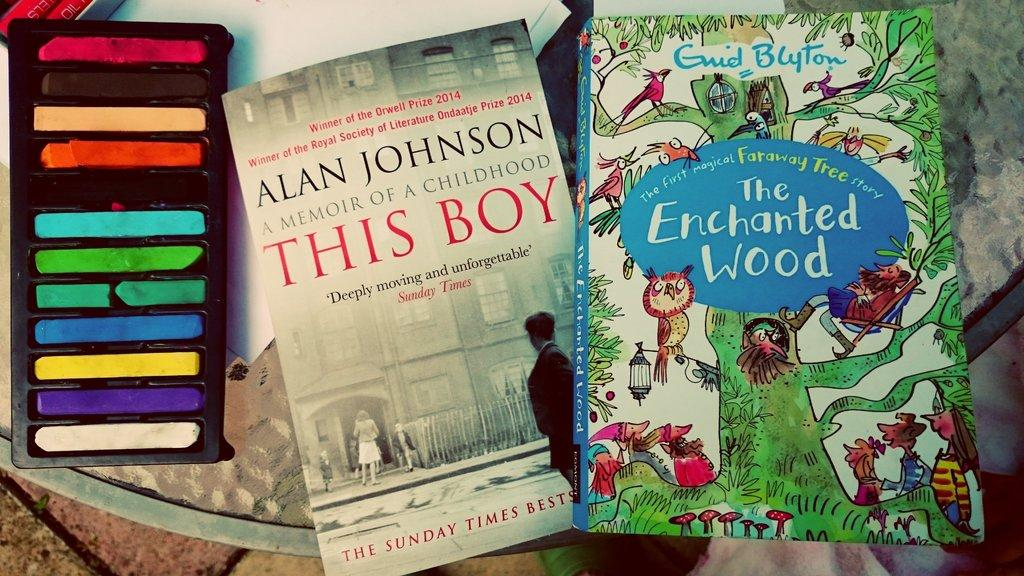<image>
Give a short and clear explanation of the subsequent image. Two books sit next to a set of pastels, one of which is The Enchanted Wood. 